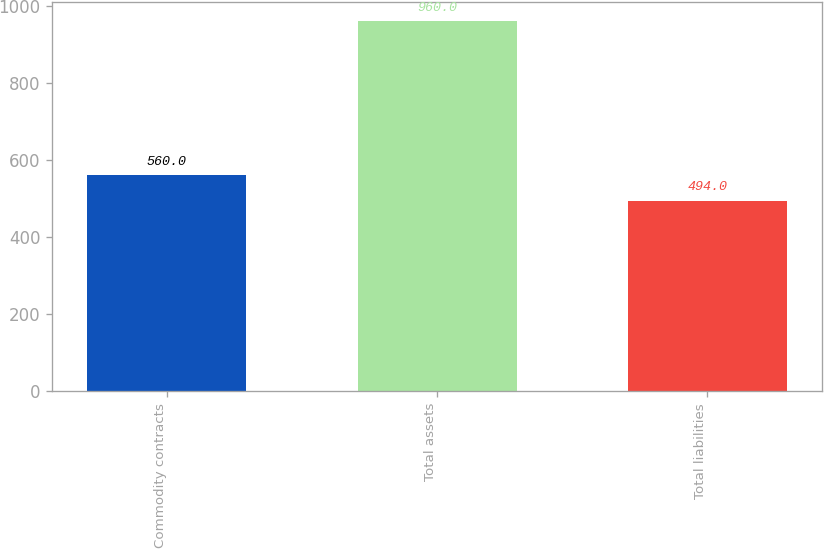Convert chart to OTSL. <chart><loc_0><loc_0><loc_500><loc_500><bar_chart><fcel>Commodity contracts<fcel>Total assets<fcel>Total liabilities<nl><fcel>560<fcel>960<fcel>494<nl></chart> 